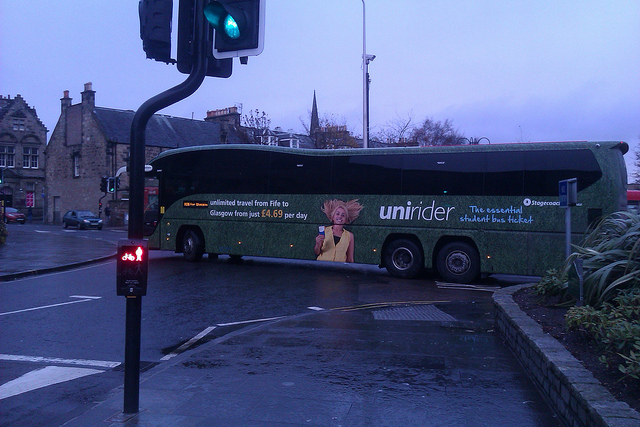If this image were part of a movie scene, what might be happening in the plot at this moment? In a movie scene, this image could depict a pivotal moment where the protagonist catches sight of the bus just in time. Perhaps they are a student who has been waiting patiently for their opportunity to travel to Glasgow for a crucial event — an audition, an important meeting, or even a reunion with an old friend. The overcast weather and the glow of the traffic light add to the tension and urgency, reflecting the high stakes of the moment and the resolve of the protagonist to seize this chance despite the seemingly mundane setting. Describe a short backstory of the bus driver in this imagined movie scene. The bus driver, Tom, has been driving this route for over two decades. A former musician, Tom has seen countless students embark on their own journeys, often reminiscing about his own youth. He knows every twist and turn between Fife and Glasgow like the back of his hand. Tom secretly enjoys being a quiet guardian to the many lives he ferries between the two cities. On this particular day, he senses something unusual in the air, a similar anticipation he felt before his own life-changing audition many years ago. Little does he know, today he is transporting a student whose destiny is about to change forever, much like his did back then. 